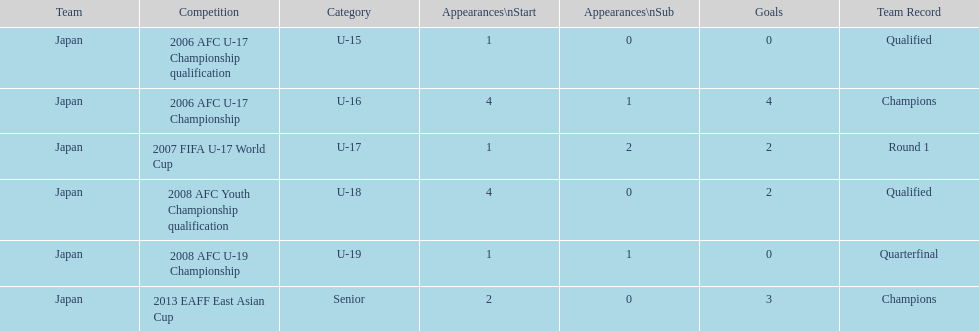What is the overall number of goals scored? 11. 